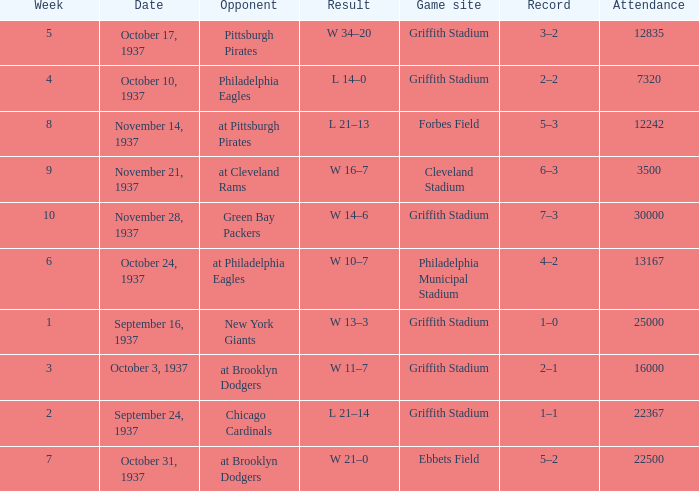What are week 4 results?  L 14–0. 